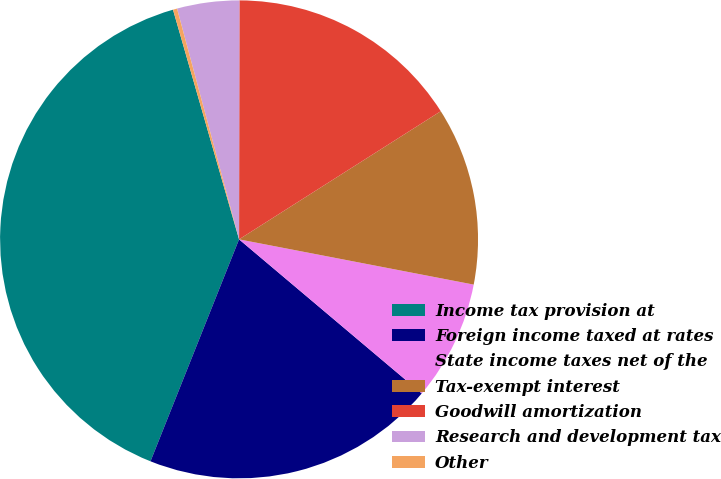Convert chart to OTSL. <chart><loc_0><loc_0><loc_500><loc_500><pie_chart><fcel>Income tax provision at<fcel>Foreign income taxed at rates<fcel>State income taxes net of the<fcel>Tax-exempt interest<fcel>Goodwill amortization<fcel>Research and development tax<fcel>Other<nl><fcel>39.5%<fcel>19.89%<fcel>8.12%<fcel>12.04%<fcel>15.97%<fcel>4.2%<fcel>0.28%<nl></chart> 